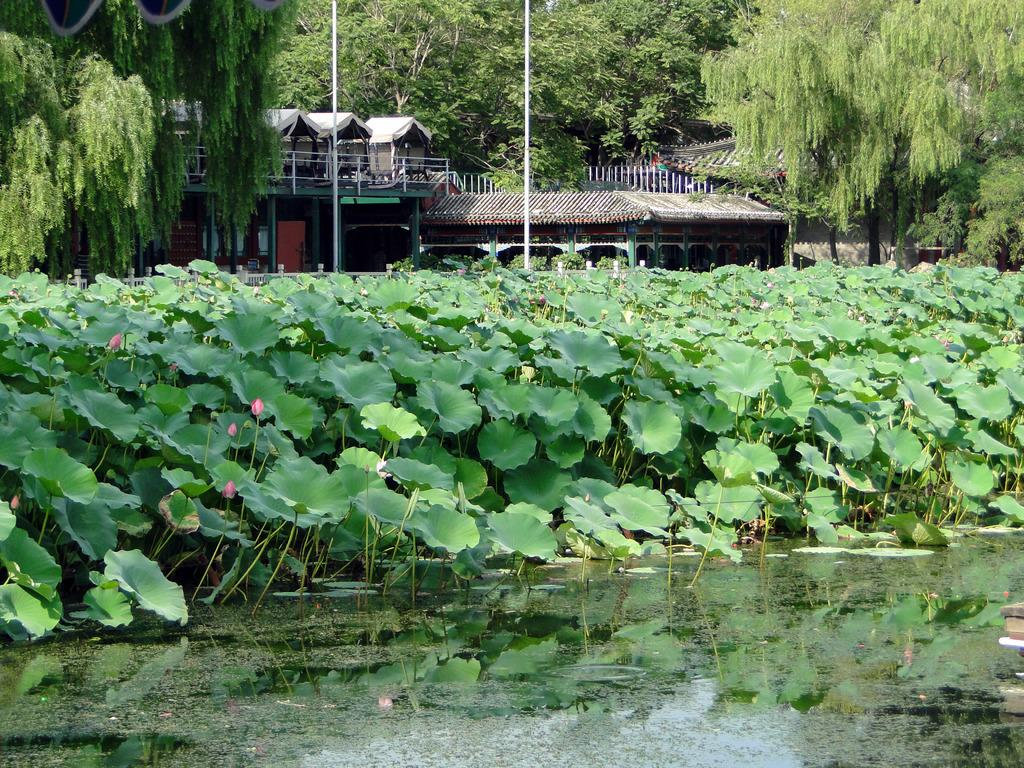What type of structures can be seen in the image? There are houses in the image. What else can be seen in the image besides houses? There are poles, trees, plants, water, a fence, and objects visible in the image. Can you describe the presence of water be confirmed in the image? Yes, there is water visible in the image. What type of natural elements are present in the image? Trees and plants are the natural elements present in the image. How many bikes are parked near the water in the image? There are no bikes present in the image. Can you describe the sea visible in the image? There is no sea visible in the image; it only contains water. 